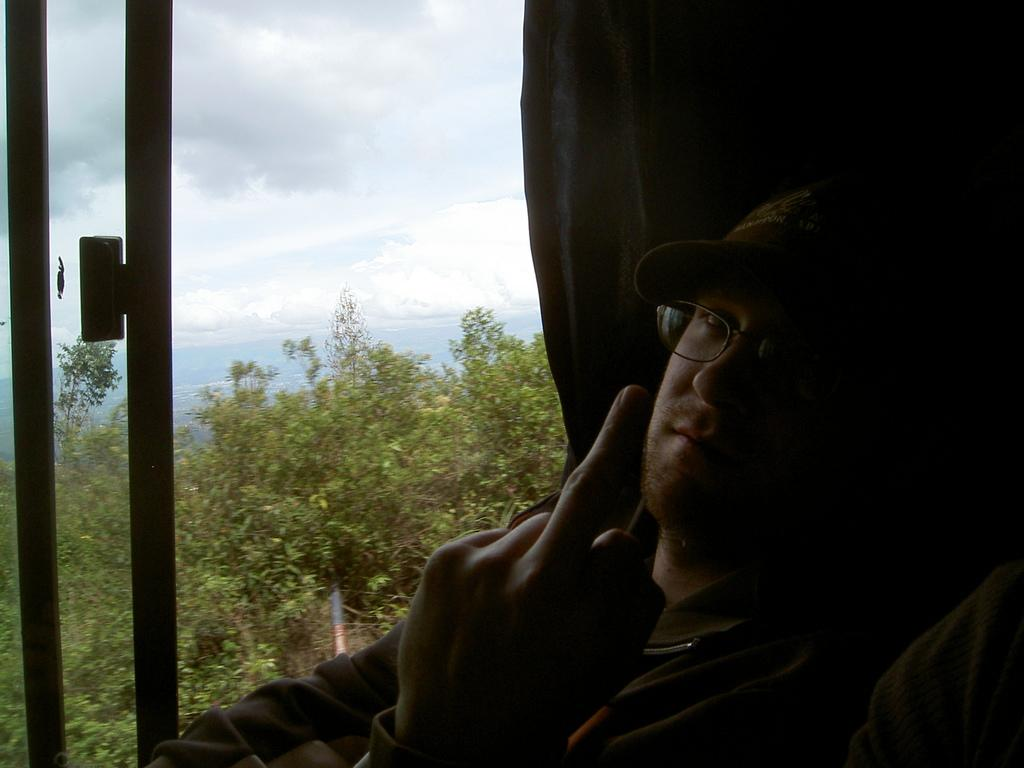Who is present in the image? There is a man in the image. What is the man doing in the image? The man is sitting on a seat. What can be seen in the background of the image? There are trees and the sky visible in the background of the image. What type of advertisement can be seen on the man's shirt in the image? There is no advertisement visible on the man's shirt in the image. What flavor of mint is the man chewing in the image? There is no mint present in the image, and the man is not chewing anything. 